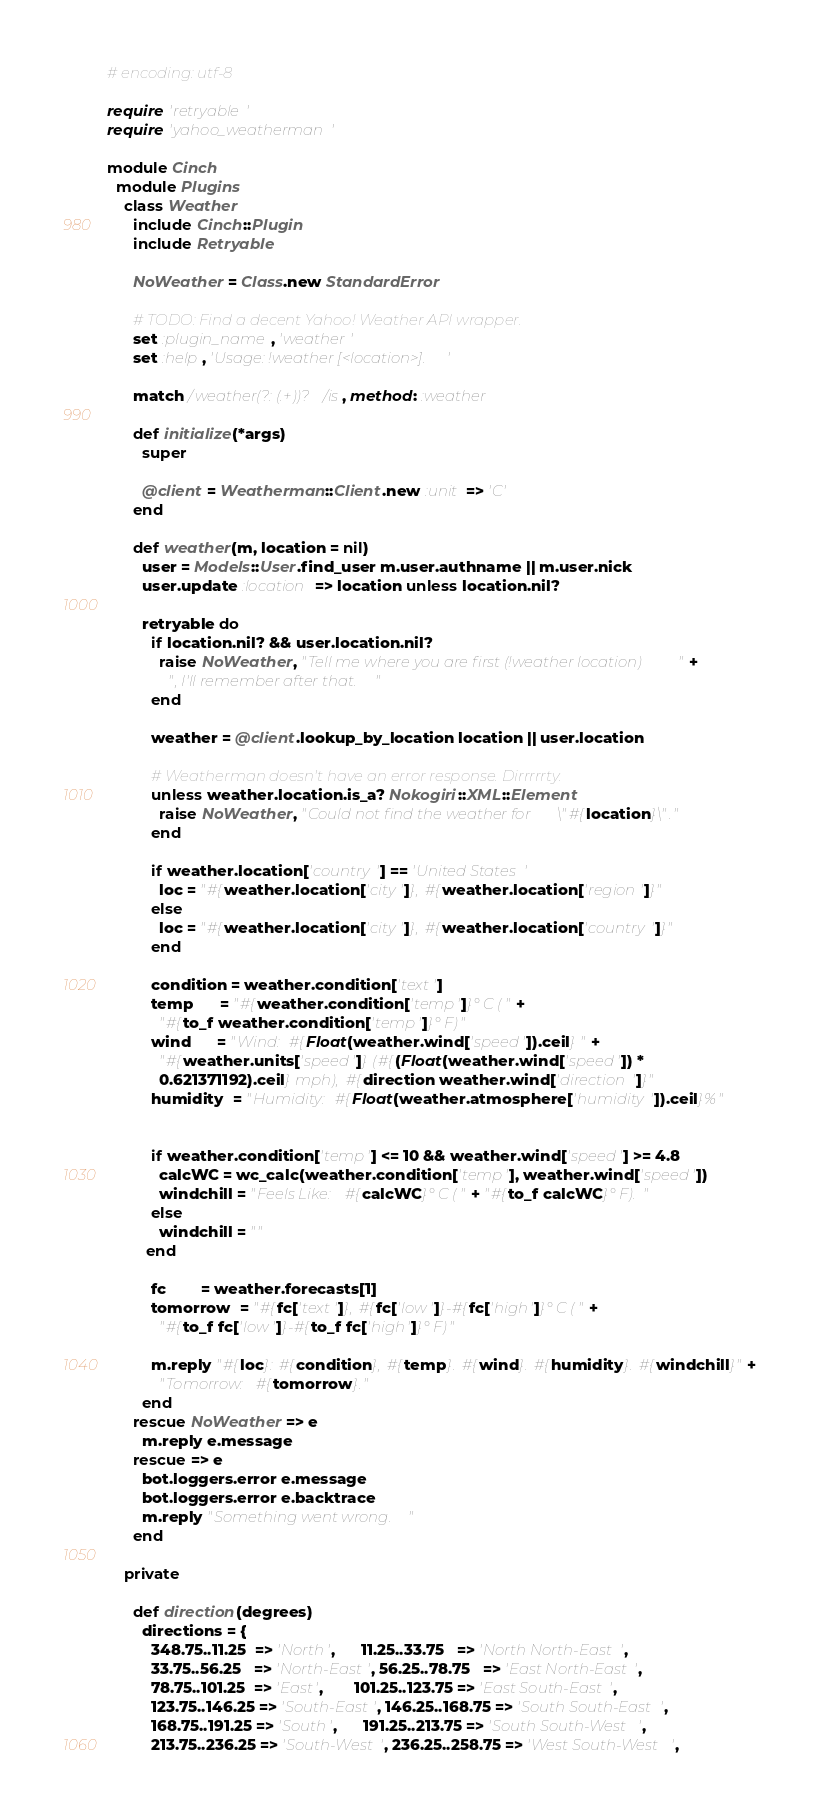Convert code to text. <code><loc_0><loc_0><loc_500><loc_500><_Ruby_># encoding: utf-8

require 'retryable'
require 'yahoo_weatherman'

module Cinch
  module Plugins
    class Weather
      include Cinch::Plugin
      include Retryable

      NoWeather = Class.new StandardError

      # TODO: Find a decent Yahoo! Weather API wrapper.
      set :plugin_name, 'weather'
      set :help, 'Usage: !weather [<location>].'

      match /weather(?: (.+))?/is, method: :weather

      def initialize(*args)
        super

        @client = Weatherman::Client.new :unit => 'C'
      end

      def weather(m, location = nil)
        user = Models::User.find_user m.user.authname || m.user.nick
        user.update :location => location unless location.nil?

        retryable do
          if location.nil? && user.location.nil?
            raise NoWeather, "Tell me where you are first (!weather location)" +
              ", I'll remember after that."
          end

          weather = @client.lookup_by_location location || user.location

          # Weatherman doesn't have an error response. Dirrrrrty.
          unless weather.location.is_a? Nokogiri::XML::Element
            raise NoWeather, "Could not find the weather for \"#{location}\"."
          end

          if weather.location['country'] == 'United States'
            loc = "#{weather.location['city']}, #{weather.location['region']}"
          else
            loc = "#{weather.location['city']}, #{weather.location['country']}"
          end

          condition = weather.condition['text']
          temp      = "#{weather.condition['temp']}° C (" +
            "#{to_f weather.condition['temp']}° F)"
          wind      = "Wind: #{Float(weather.wind['speed']).ceil} " +
            "#{weather.units['speed']} (#{(Float(weather.wind['speed']) * 
            0.621371192).ceil} mph), #{direction weather.wind['direction']}"
          humidity  = "Humidity: #{Float(weather.atmosphere['humidity']).ceil}%"
          

          if weather.condition['temp'] <= 10 && weather.wind['speed'] >= 4.8
            calcWC = wc_calc(weather.condition['temp'], weather.wind['speed'])
            windchill = "Feels Like: #{calcWC}° C (" + "#{to_f calcWC}° F). "
          else
            windchill = ""
         end

          fc        = weather.forecasts[1]
          tomorrow  = "#{fc['text']}, #{fc['low']}-#{fc['high']}° C (" +
            "#{to_f fc['low']}-#{to_f fc['high']}° F)"

          m.reply "#{loc}: #{condition}, #{temp}. #{wind}. #{humidity}. #{windchill}" +
            "Tomorrow: #{tomorrow}."
        end
      rescue NoWeather => e
        m.reply e.message
      rescue => e 
        bot.loggers.error e.message
        bot.loggers.error e.backtrace
        m.reply "Something went wrong."
      end

    private

      def direction(degrees)
        directions = { 
          348.75..11.25  => 'North',      11.25..33.75   => 'North North-East', 
          33.75..56.25   => 'North-East', 56.25..78.75   => 'East North-East',
          78.75..101.25  => 'East',       101.25..123.75 => 'East South-East',
          123.75..146.25 => 'South-East', 146.25..168.75 => 'South South-East',
          168.75..191.25 => 'South',      191.25..213.75 => 'South South-West',
          213.75..236.25 => 'South-West', 236.25..258.75 => 'West South-West',</code> 